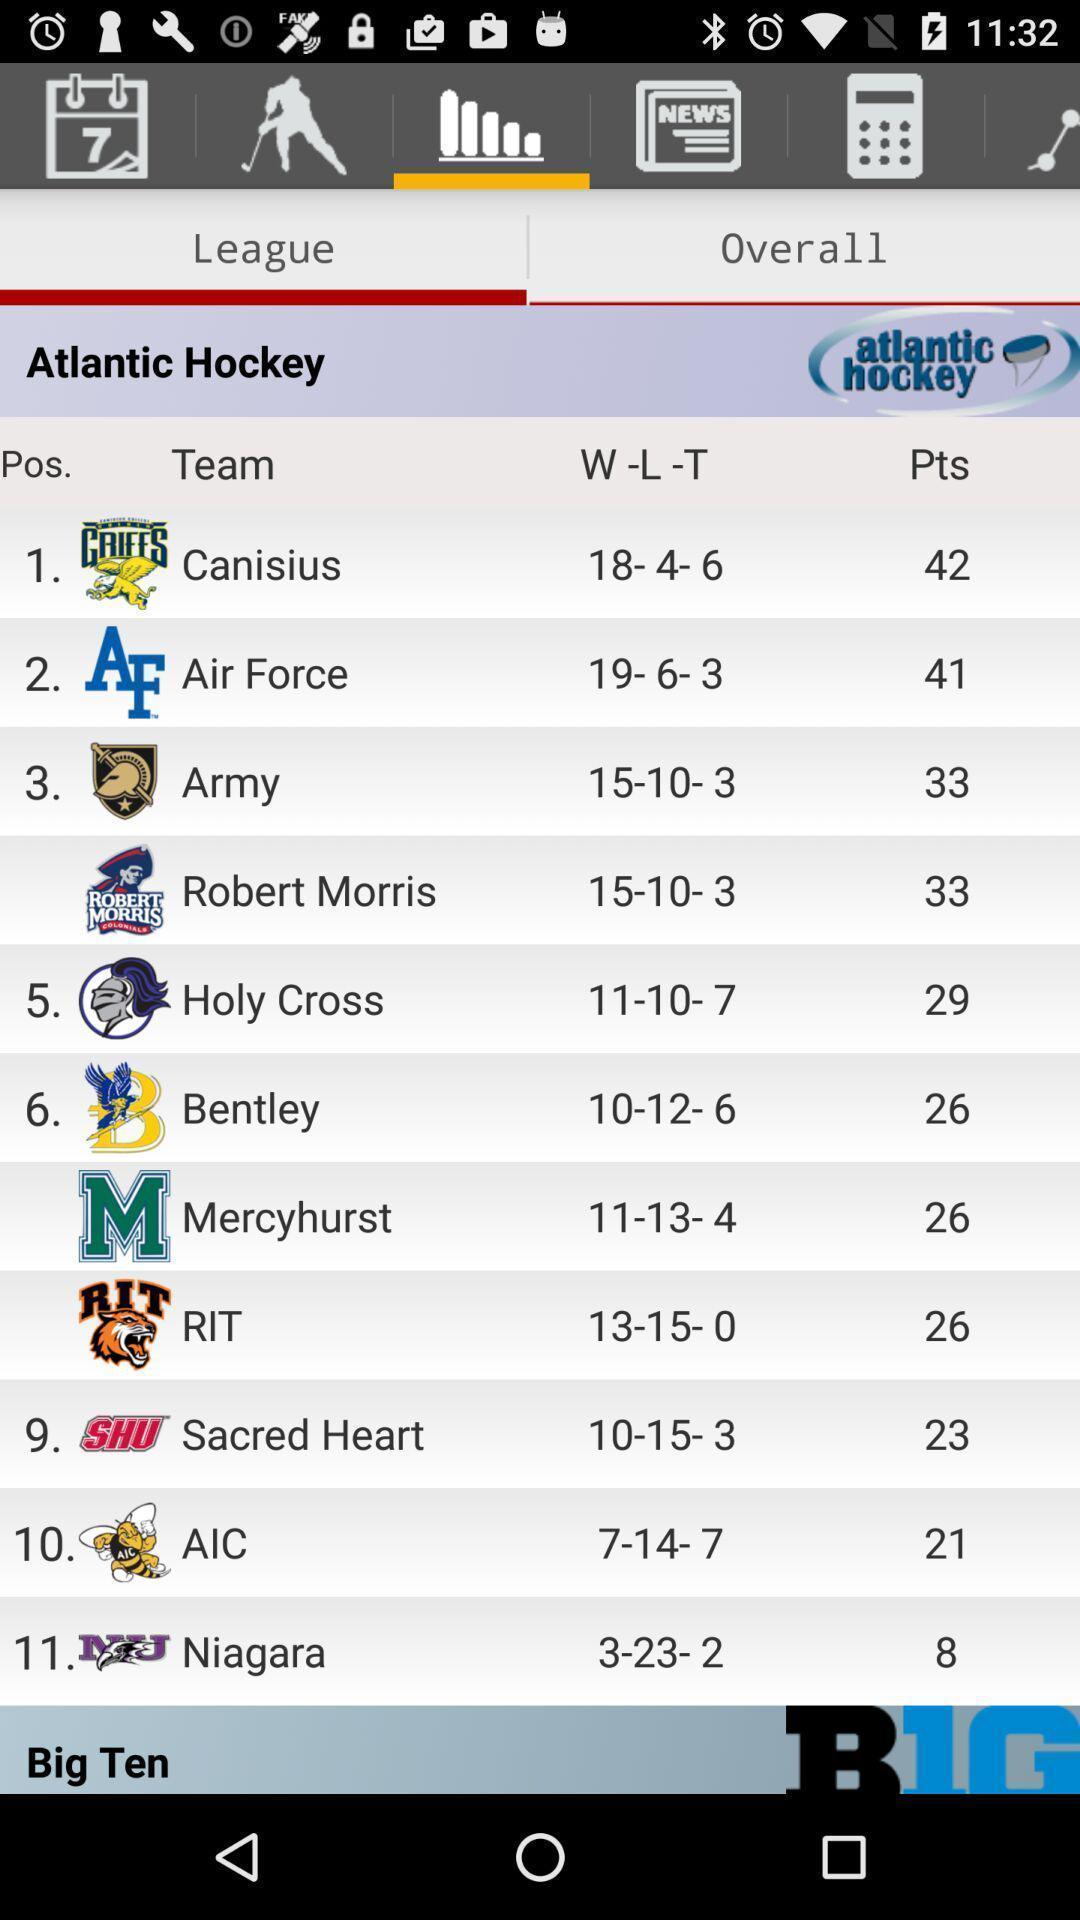Explain what's happening in this screen capture. Pop-up showing team stats in a sports app. 